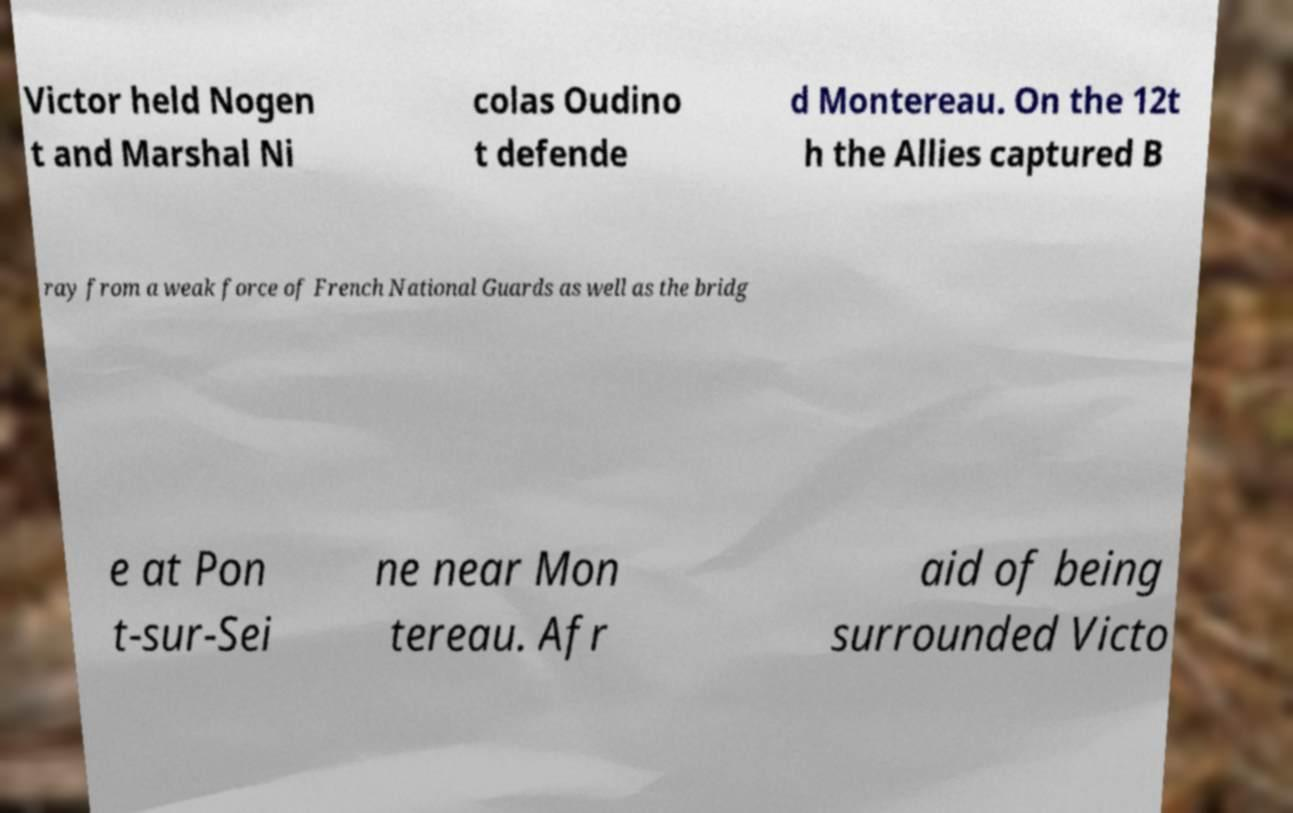What messages or text are displayed in this image? I need them in a readable, typed format. Victor held Nogen t and Marshal Ni colas Oudino t defende d Montereau. On the 12t h the Allies captured B ray from a weak force of French National Guards as well as the bridg e at Pon t-sur-Sei ne near Mon tereau. Afr aid of being surrounded Victo 